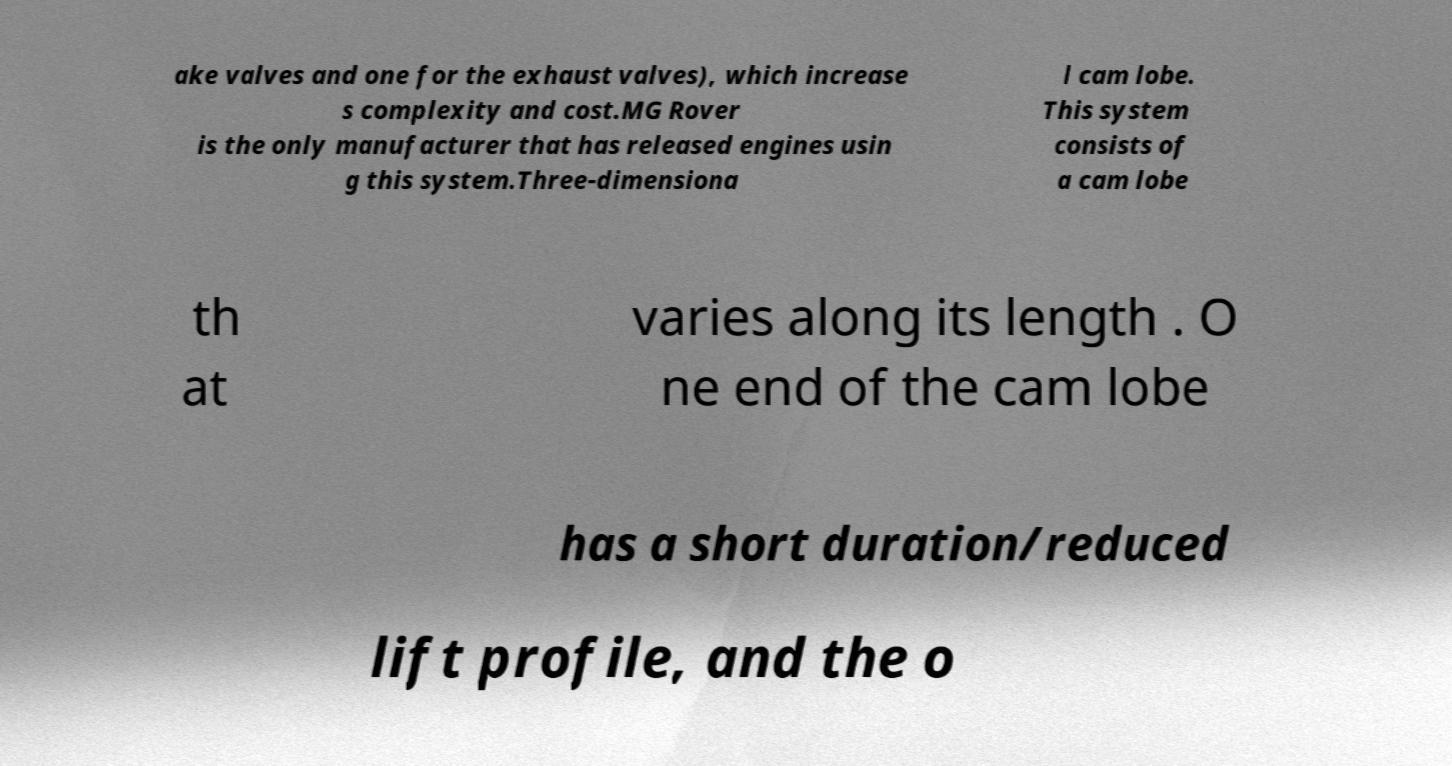Could you extract and type out the text from this image? ake valves and one for the exhaust valves), which increase s complexity and cost.MG Rover is the only manufacturer that has released engines usin g this system.Three-dimensiona l cam lobe. This system consists of a cam lobe th at varies along its length . O ne end of the cam lobe has a short duration/reduced lift profile, and the o 